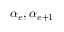<formula> <loc_0><loc_0><loc_500><loc_500>\alpha _ { e } , \alpha _ { e + 1 }</formula> 